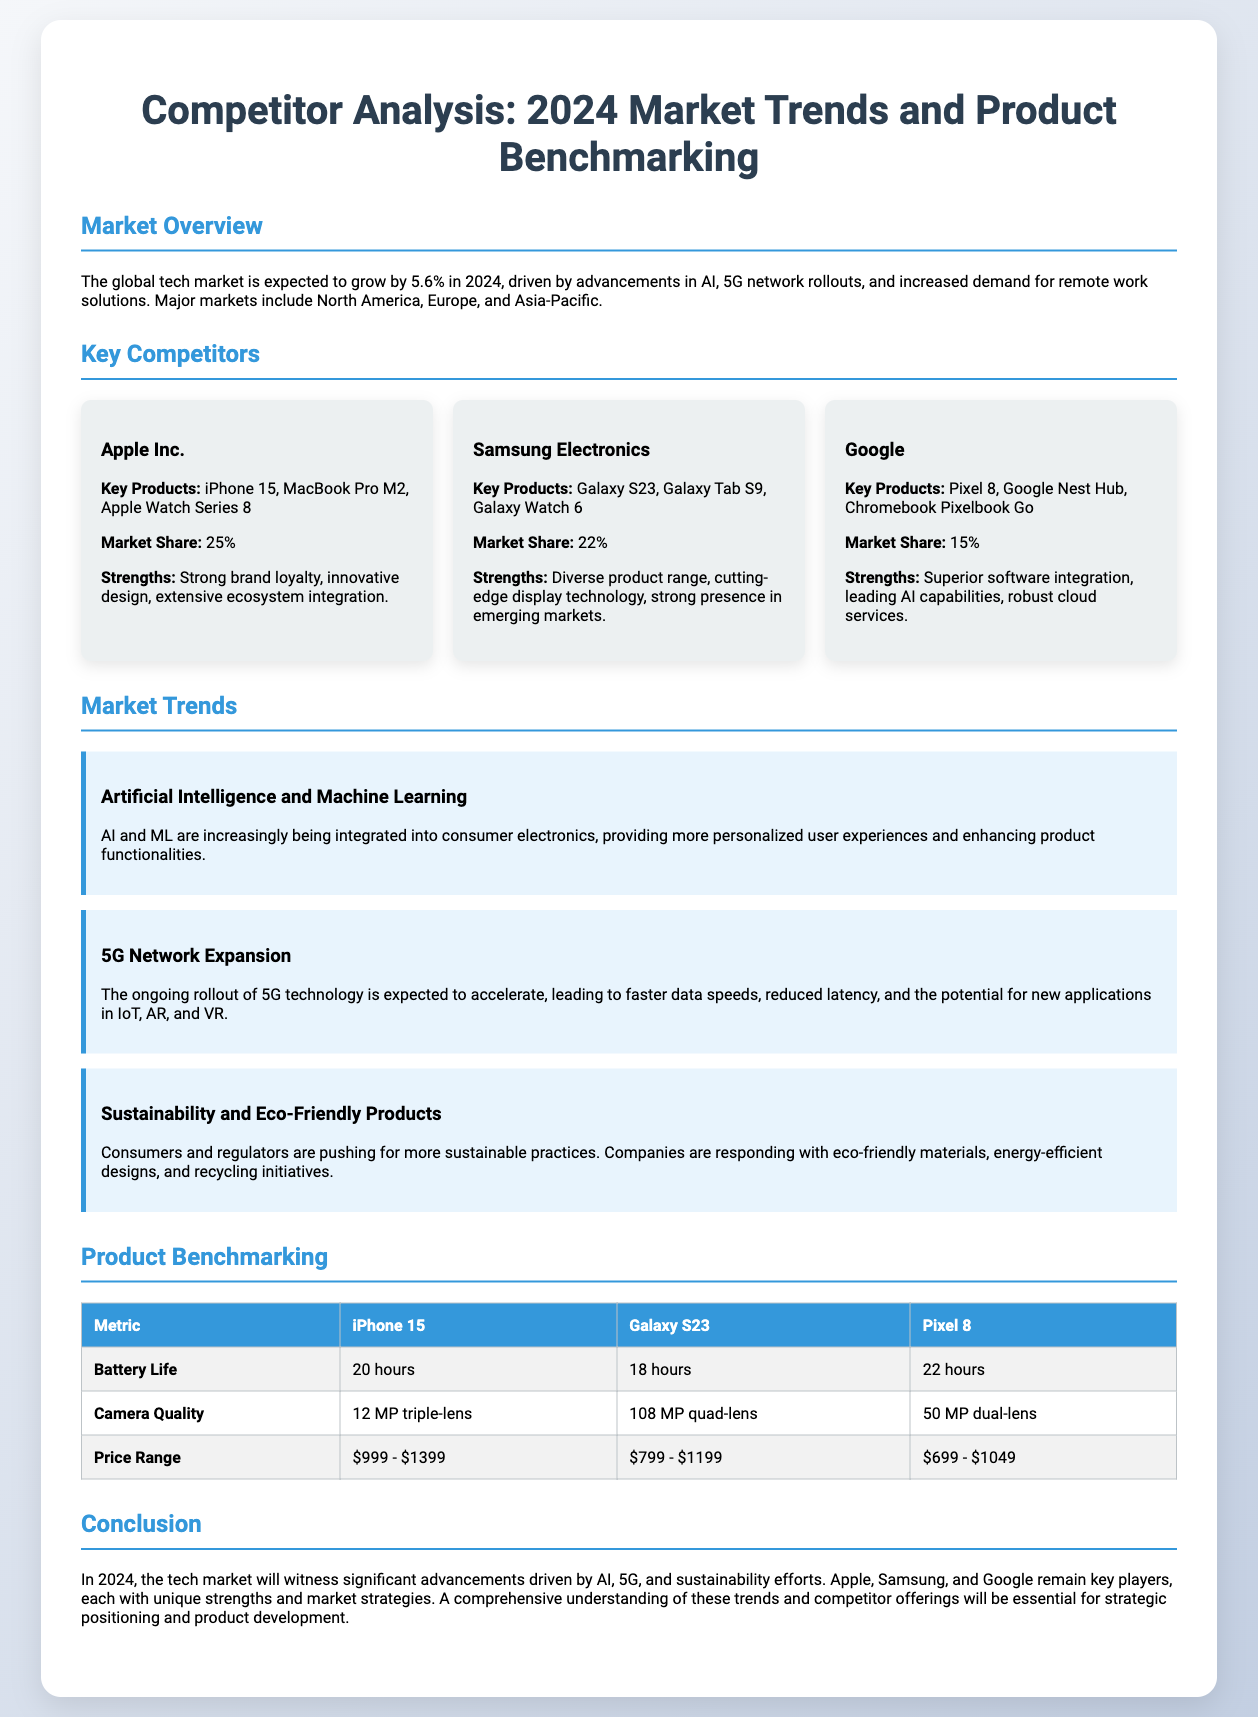what is the expected growth rate of the global tech market in 2024? The document states that the global tech market is expected to grow by 5.6% in 2024.
Answer: 5.6% which competitor has the highest market share? According to the slide, Apple Inc. has a market share of 25%, the highest among competitors.
Answer: 25% what are the key products of Samsung Electronics? The document lists Galaxy S23, Galaxy Tab S9, and Galaxy Watch 6 as key products of Samsung Electronics.
Answer: Galaxy S23, Galaxy Tab S9, Galaxy Watch 6 what trend is associated with faster data speeds and reduced latency? The ongoing rollout of 5G technology is linked to faster data speeds and reduced latency.
Answer: 5G Network Expansion which product has the longest battery life according to the benchmarking table? The benchmarking table indicates that the Pixel 8 has the longest battery life at 22 hours.
Answer: 22 hours which competitor has a stronger brand loyalty? Apple Inc. is noted in the document for having strong brand loyalty as a key strength.
Answer: Apple Inc what is the price range of the iPhone 15? The slide specifies that the price range for the iPhone 15 is $999 - $1399.
Answer: $999 - $1399 what sustainability trend is highlighted in the document? The slide discusses sustainability and eco-friendly products as a key market trend.
Answer: Sustainability and Eco-Friendly Products which competitor is recognized for superior software integration? Google is highlighted for its superior software integration among its strengths.
Answer: Google 